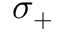<formula> <loc_0><loc_0><loc_500><loc_500>\sigma _ { + }</formula> 